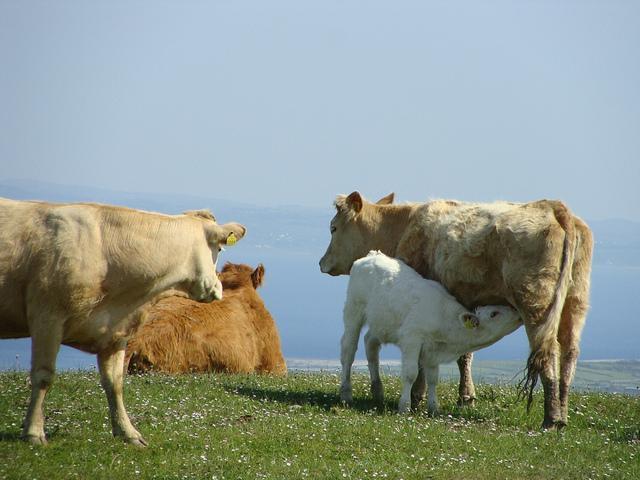How many adult cows are in the photo?
Give a very brief answer. 3. How many cows are there?
Give a very brief answer. 4. How many books are in the picture?
Give a very brief answer. 0. 